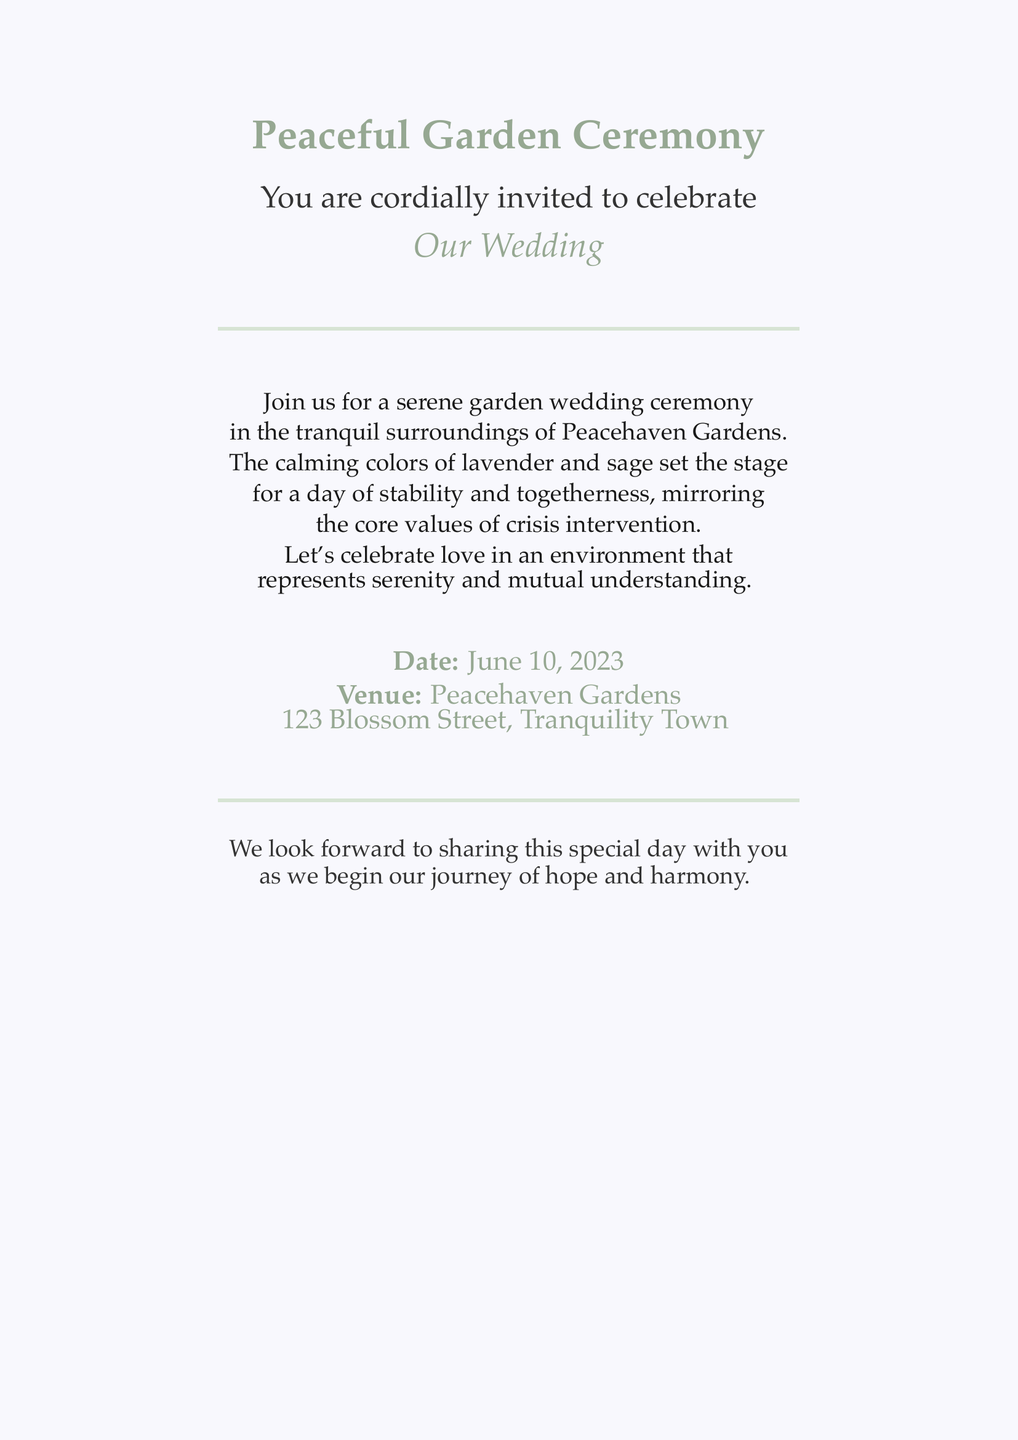What is the theme of the wedding? The theme of the wedding is highlighted in the title of the invitation, which describes the event as a "Peaceful Garden Ceremony."
Answer: Peaceful Garden Ceremony Where is the wedding venue located? The venue is mentioned in the invitation text, specifying "Peacehaven Gardens" as the location.
Answer: Peacehaven Gardens What date will the wedding take place? The date is directly stated in the invitation under the information section.
Answer: June 10, 2023 Which colors are featured in the wedding invitation? The colors are mentioned in the text describing the calming colors, specifically lavender and sage.
Answer: Lavender and sage What values does the wedding ceremony reflect? The invitation mentions it reflects core values associated with crisis intervention, notably in the description of the atmosphere.
Answer: Serenity and mutual understanding What kind of ceremony is this? The document specifies the nature of the gathering as a wedding ceremony, indicated by phrases like "Our Wedding."
Answer: Wedding How does the invitation describe the atmosphere? The atmosphere is defined in the description section, emphasizing tranquility and a sense of togetherness.
Answer: Tranquil Who is invited to the wedding? The invitation states "You are cordially invited" indicating the guests addressed are individuals receiving the invitation.
Answer: You What is the purpose of the gathering? The invitation's text indicates the purpose as a celebration of love, specifically marking the beginning of a journey.
Answer: Celebrate love 